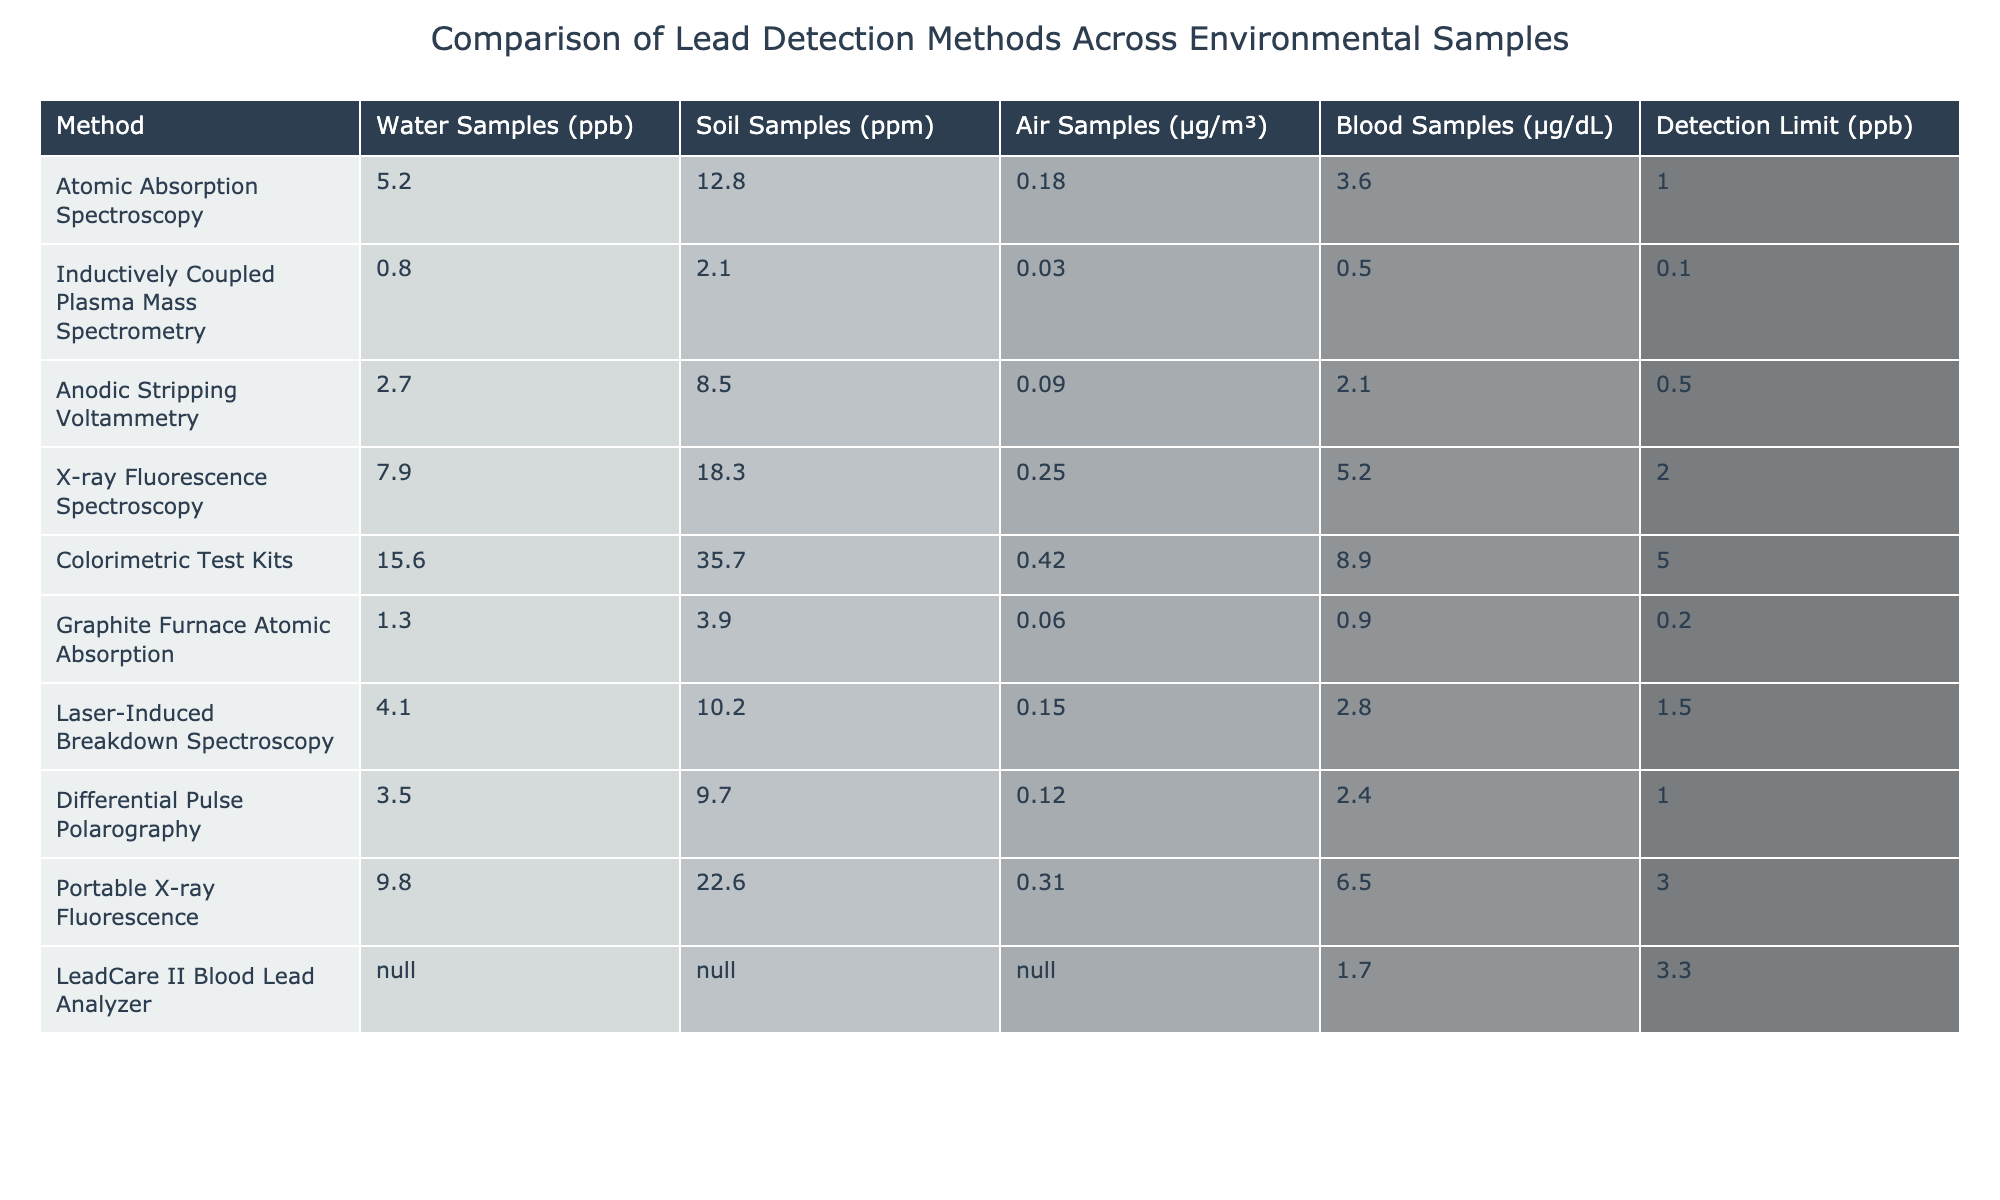What is the detection limit of Inductively Coupled Plasma Mass Spectrometry? The detection limit for Inductively Coupled Plasma Mass Spectrometry is listed in the table under the respective column, and it shows as 0.1 ppb.
Answer: 0.1 ppb Which method has the highest lead concentration in soil samples? Looking at the soil samples column, the method that shows the highest concentration is Colorimetric Test Kits, with a value of 35.7 ppm.
Answer: Colorimetric Test Kits Is Laser-Induced Breakdown Spectroscopy more effective than Graphite Furnace Atomic Absorption for detecting lead in water? Comparing the water samples column, Laser-Induced Breakdown Spectroscopy has a reading of 4.1 ppb, while Graphite Furnace Atomic Absorption has 1.3 ppb. Since 4.1 is greater than 1.3, it is more effective.
Answer: Yes What is the difference in lead concentration between Colorimetric Test Kits and X-ray Fluorescence Spectroscopy in soil samples? For Colorimetric Test Kits, the value is 35.7 ppm, and for X-ray Fluorescence Spectroscopy, it is 18.3 ppm. The difference is calculated as 35.7 - 18.3 = 17.4 ppm.
Answer: 17.4 ppm Which detection method is used for blood samples that has the lowest detection limit? Looking at the blood samples column, LeadCare II Blood Lead Analyzer has a detection limit of 3.3 ppb, and this is lower than all other methods listed for blood samples.
Answer: LeadCare II Blood Lead Analyzer What is the average lead concentration for water samples across all methods listed? To find the average, first, sum the water sample values for all methods, which results in 5.2 + 0.8 + 2.7 + 7.9 + 15.6 + 1.3 + 4.1 + 3.5 + 9.8 = 50.9 ppb. Then divide by the number of methods, which is 9. Therefore, the average is 50.9 / 9 = approximately 5.66 ppb.
Answer: Approximately 5.66 ppb Does any method have a detection limit below 1 ppb? Reviewing the detection limits column, Inductively Coupled Plasma Mass Spectrometry has a detection limit of 0.1 ppb, which is below 1 ppb.
Answer: Yes If you rank the methods based on lead concentration in air samples, which is the second highest? Analyzing the air samples column, the highest is Colorimetric Test Kits (0.42 µg/m³), and the second highest is Portable X-ray Fluorescence (0.31 µg/m³).
Answer: Portable X-ray Fluorescence 